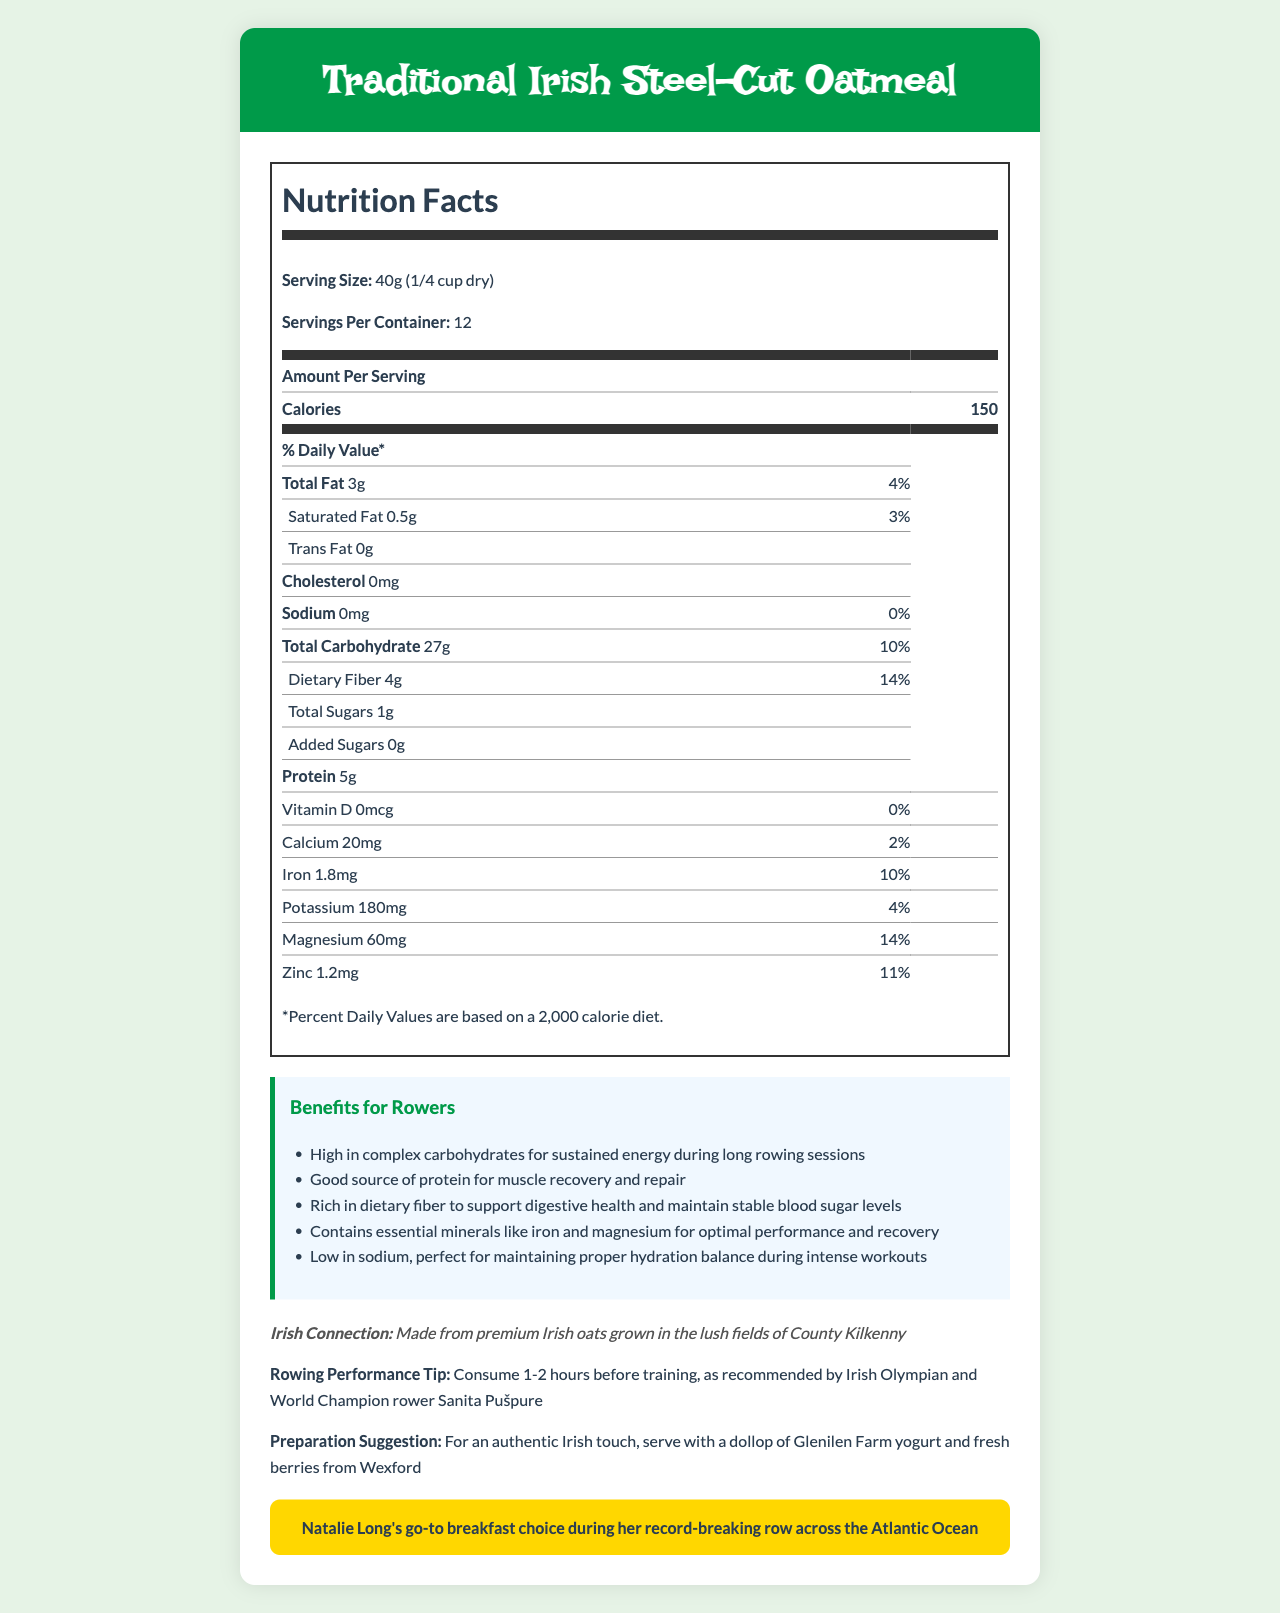what is the total fat per serving? The total fat per serving is specified in the Nutrition Facts section as 3g.
Answer: 3g what is the source of the oats used in this product? The Irish Connection section mentions that the oats are grown in the lush fields of County Kilkenny.
Answer: County Kilkenny how much dietary fiber does one serving contain? The amount of dietary fiber per serving is listed as 4g in the Nutrition Facts section.
Answer: 4g what is the daily value percentage of magnesium in one serving? In the Nutrition Facts section, it states that one serving provides 14% of the daily value for magnesium.
Answer: 14% what is Natalie's endorsement about this product? The endorsement section mentions that Traditional Irish Steel-Cut Oatmeal is Natalie Long's go-to breakfast choice during her record-breaking row across the Atlantic Ocean.
Answer: Natalie Long's go-to breakfast choice during her record-breaking row across the Atlantic Ocean how much protein does one serving contain? A. 3g B. 4g C. 5g D. 10g The protein content per serving is listed as 5g in the Nutrition Facts section.
Answer: C. 5g which vitamin is entirely absent in this product per serving? A. Vitamin D B. Calcium C. Iron D. Magnesium According to the Nutrition Facts, Vitamin D is listed with an amount of 0mcg, meaning it is absent in this product.
Answer: A. Vitamin D Is this product low in sodium? The Nutrition Facts list sodium as 0mg per serving, indicating it is low in sodium.
Answer: Yes summarize the benefits of Traditional Irish Steel-Cut Oatmeal for rowers. The benefits for rowers section highlighted these key points, explaining why the oatmeal can be particularly advantageous for athletes engaged in rowing.
Answer: Traditional Irish Steel-Cut Oatmeal offers several benefits for rowers, including providing sustained energy, muscle recovery support, stable blood sugar levels, essential minerals for performance and recovery, and low sodium content for hydration. does this product contain any added sugars? The Nutrition Facts state that the total added sugars per serving are 0g, indicating there are no added sugars in this product.
Answer: No how many servings does the container hold? The servings per container are listed as 12 in the Nutrition Facts section.
Answer: 12 how many calories are in one serving? The calories per serving are listed as 150 in the Nutrition Facts section.
Answer: 150 how much potassium does one serving provide? The Nutrition Facts indicates that one serving includes 180mg of potassium.
Answer: 180mg what is the authentic Irish preparation suggestion for this oatmeal? The preparation suggestion section recommends serving with a dollop of Glenilen Farm yogurt and fresh berries from Wexford for an authentic Irish touch.
Answer: Serve with a dollop of Glenilen Farm yogurt and fresh berries from Wexford how much calcium does one serving have? The Nutrition Facts list the calcium content per serving as 20mg.
Answer: 20mg who else recommends the timing of consuming this oatmeal before training? The rowing performance tip section advises consumption 1-2 hours before training as recommended by Sanita Pušpure.
Answer: Sanita Pušpure, Irish Olympian and World Champion rower what kinds of fats are in this product? The Nutrition Facts list total fat as 3g and saturated fat as 0.5g, while trans fat is 0g.
Answer: Total fat and saturated fat Is the exact origin of the oats grown mentioned? The oats are mentioned to be from the lush fields of County Kilkenny.
Answer: Yes how many grams of carbohydrates does one serving contain? The total carbohydrate content per serving is listed as 27g in the Nutrition Facts section.
Answer: 27g is magnesium content provided in milligrams or as a percentage of daily value? The Nutrition Facts section provides magnesium content both as 60mg and as 14% of the daily value.
Answer: Both can I determine how this oatmeal affects hydration balance? The document mentions the low sodium content is good for hydration balance, but does not provide detailed scientific information on the effect on hydration beyond this.
Answer: Not enough information what is the percent daily value of saturated fat per serving? The Nutrition Facts section states that the percent daily value of saturated fat is 3% per serving.
Answer: 3% 